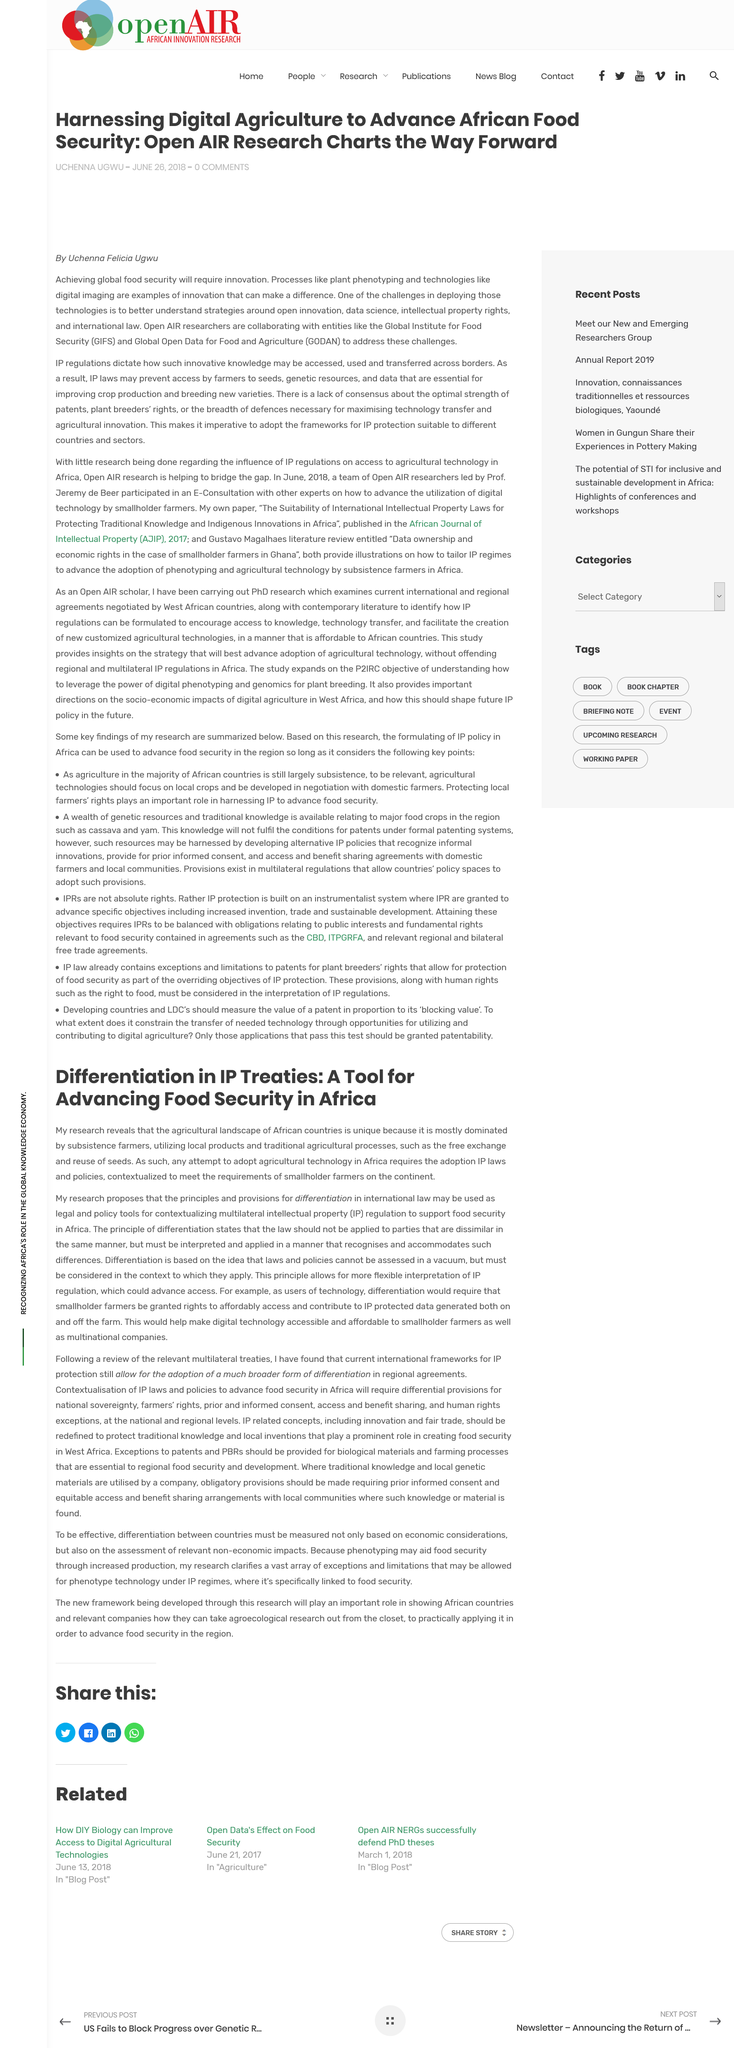Indicate a few pertinent items in this graphic. The farmers interviewed in the study primarily use local products. Subsistence farmers dominate the agricultural landscape of Africa. The continent mentioned in the text is Africa. 